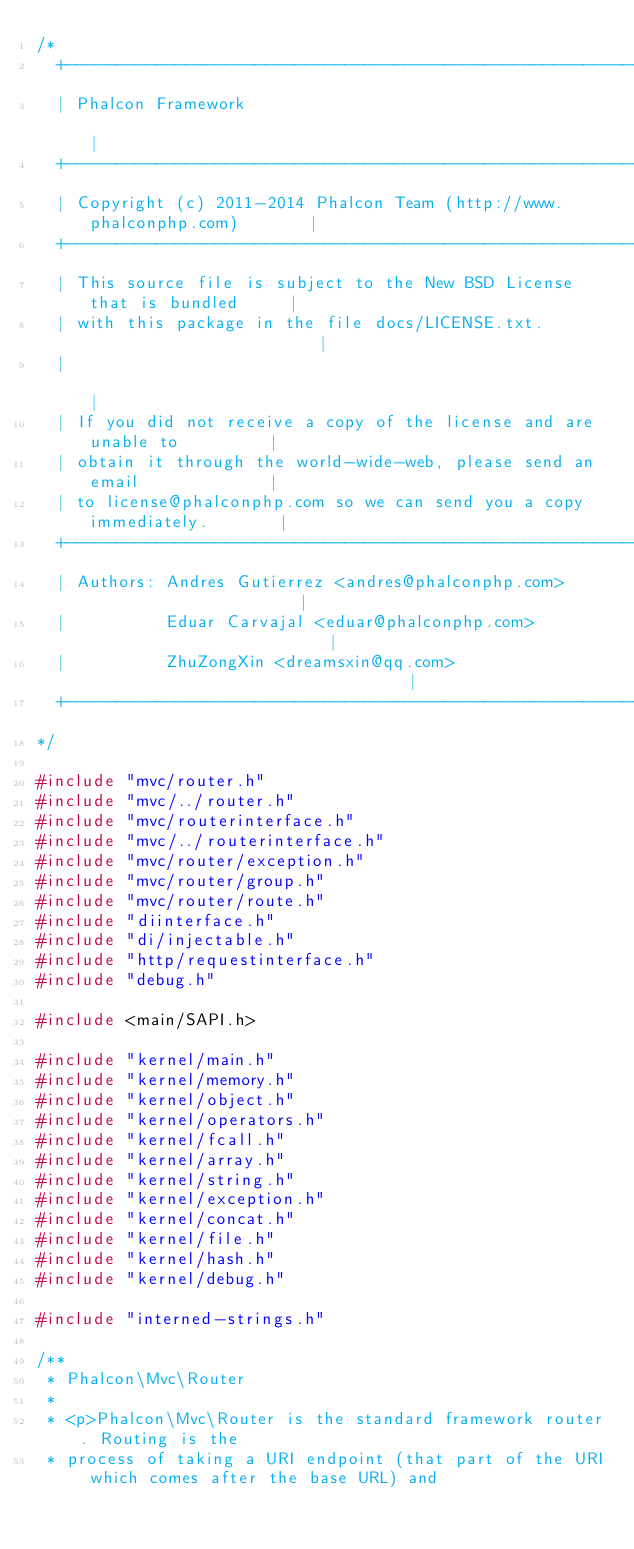<code> <loc_0><loc_0><loc_500><loc_500><_C_>/*
  +------------------------------------------------------------------------+
  | Phalcon Framework                                                      |
  +------------------------------------------------------------------------+
  | Copyright (c) 2011-2014 Phalcon Team (http://www.phalconphp.com)       |
  +------------------------------------------------------------------------+
  | This source file is subject to the New BSD License that is bundled     |
  | with this package in the file docs/LICENSE.txt.                        |
  |                                                                        |
  | If you did not receive a copy of the license and are unable to         |
  | obtain it through the world-wide-web, please send an email             |
  | to license@phalconphp.com so we can send you a copy immediately.       |
  +------------------------------------------------------------------------+
  | Authors: Andres Gutierrez <andres@phalconphp.com>                      |
  |          Eduar Carvajal <eduar@phalconphp.com>                         |
  |          ZhuZongXin <dreamsxin@qq.com>                                 |
  +------------------------------------------------------------------------+
*/

#include "mvc/router.h"
#include "mvc/../router.h"
#include "mvc/routerinterface.h"
#include "mvc/../routerinterface.h"
#include "mvc/router/exception.h"
#include "mvc/router/group.h"
#include "mvc/router/route.h"
#include "diinterface.h"
#include "di/injectable.h"
#include "http/requestinterface.h"
#include "debug.h"

#include <main/SAPI.h>

#include "kernel/main.h"
#include "kernel/memory.h"
#include "kernel/object.h"
#include "kernel/operators.h"
#include "kernel/fcall.h"
#include "kernel/array.h"
#include "kernel/string.h"
#include "kernel/exception.h"
#include "kernel/concat.h"
#include "kernel/file.h"
#include "kernel/hash.h"
#include "kernel/debug.h"

#include "interned-strings.h"

/**
 * Phalcon\Mvc\Router
 *
 * <p>Phalcon\Mvc\Router is the standard framework router. Routing is the
 * process of taking a URI endpoint (that part of the URI which comes after the base URL) and</code> 